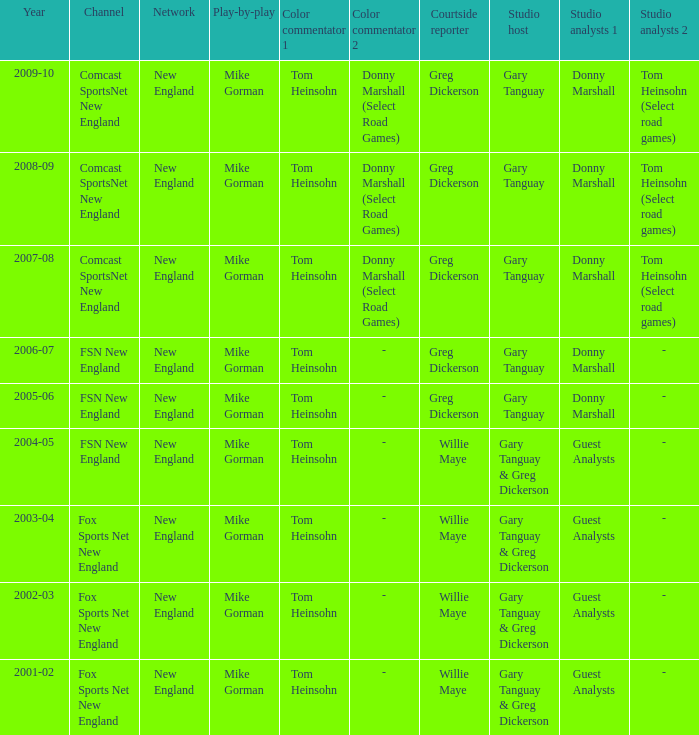Who are the studio analysts for the year 2008-09? Donny Marshall or Tom Heinsohn (Select road games). 